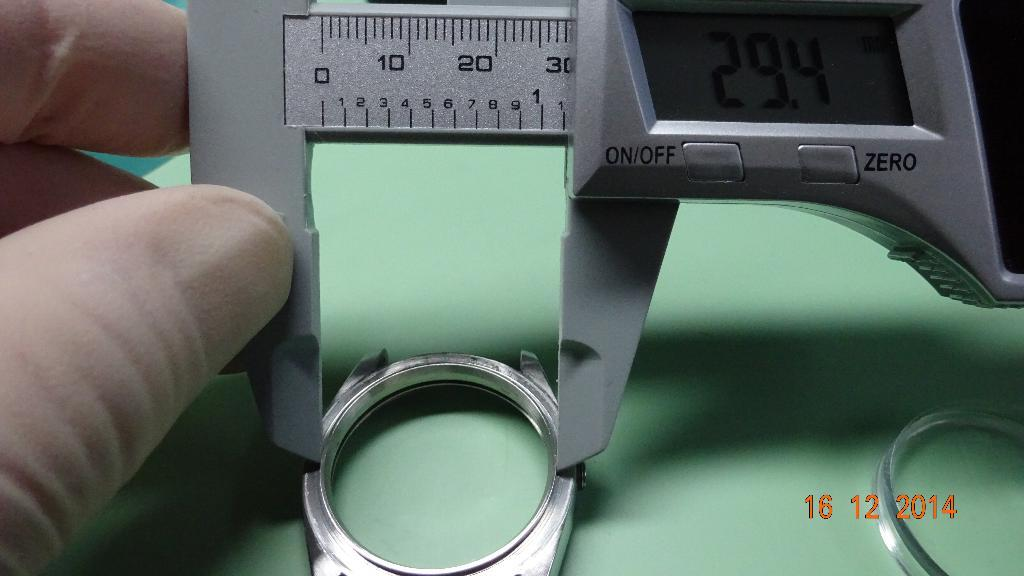<image>
Render a clear and concise summary of the photo. a digital micrometer gauge with a zero out button 